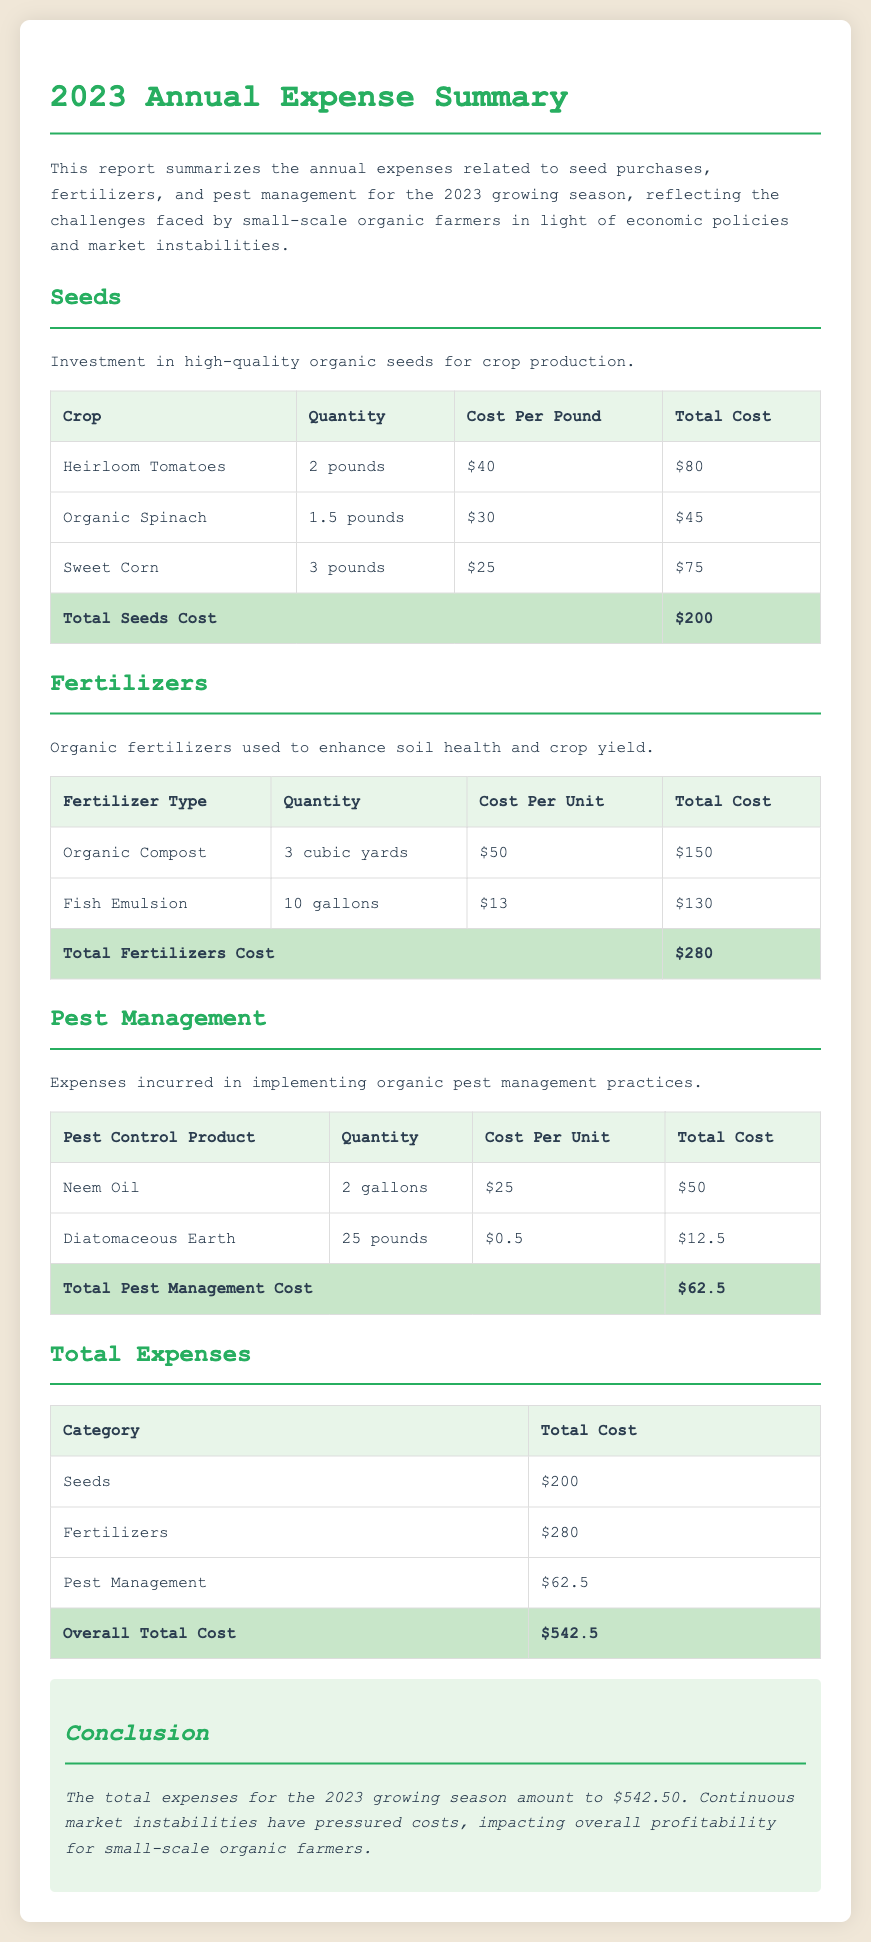What is the total cost of seeds? The total cost of seeds is summarized in the document, which shows $200.
Answer: $200 How much was spent on fertilizers? The total fertilizers cost is noted in the table as $280.
Answer: $280 What is the cost of Neem Oil? The cost of Neem Oil, which is listed in the pest management section, is $25 per gallon.
Answer: $25 What is the total cost of pest management? The overall cost for pest management is specified as $62.5.
Answer: $62.5 How many pounds of Diatomaceous Earth were purchased? The document indicates that 25 pounds of Diatomaceous Earth were bought for pest management.
Answer: 25 pounds What is the overall total cost for all expenses? The total expenses for 2023, displayed in a summary table, amount to $542.5.
Answer: $542.5 What crop has the highest seed cost per pound? Among the seeds listed, Heirloom Tomatoes have the highest cost per pound at $40.
Answer: Heirloom Tomatoes How many gallons of Fish Emulsion were used? The summary shows that 10 gallons of Fish Emulsion were purchased for fertilizers.
Answer: 10 gallons What is the total investment in organic seeds? The investment in seeds is calculated from the total seeds cost, which is $200.
Answer: $200 